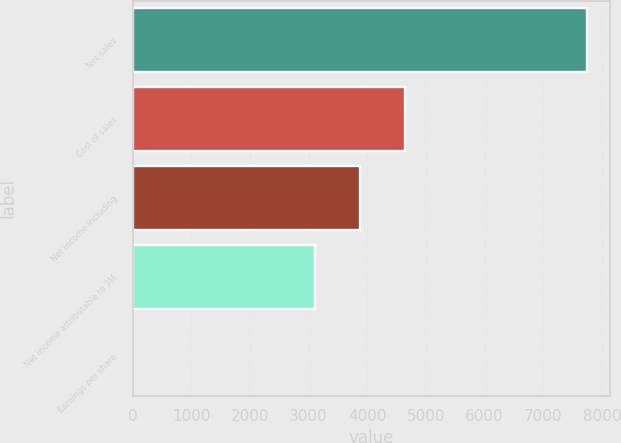Convert chart. <chart><loc_0><loc_0><loc_500><loc_500><bar_chart><fcel>Net sales<fcel>Cost of sales<fcel>Net income including<fcel>Net income attributable to 3M<fcel>Earnings per share<nl><fcel>7752<fcel>4651.84<fcel>3876.81<fcel>3101.78<fcel>1.66<nl></chart> 